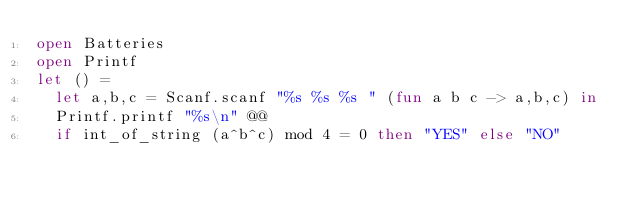Convert code to text. <code><loc_0><loc_0><loc_500><loc_500><_OCaml_>open Batteries
open Printf
let () =
  let a,b,c = Scanf.scanf "%s %s %s " (fun a b c -> a,b,c) in
  Printf.printf "%s\n" @@
  if int_of_string (a^b^c) mod 4 = 0 then "YES" else "NO"


</code> 